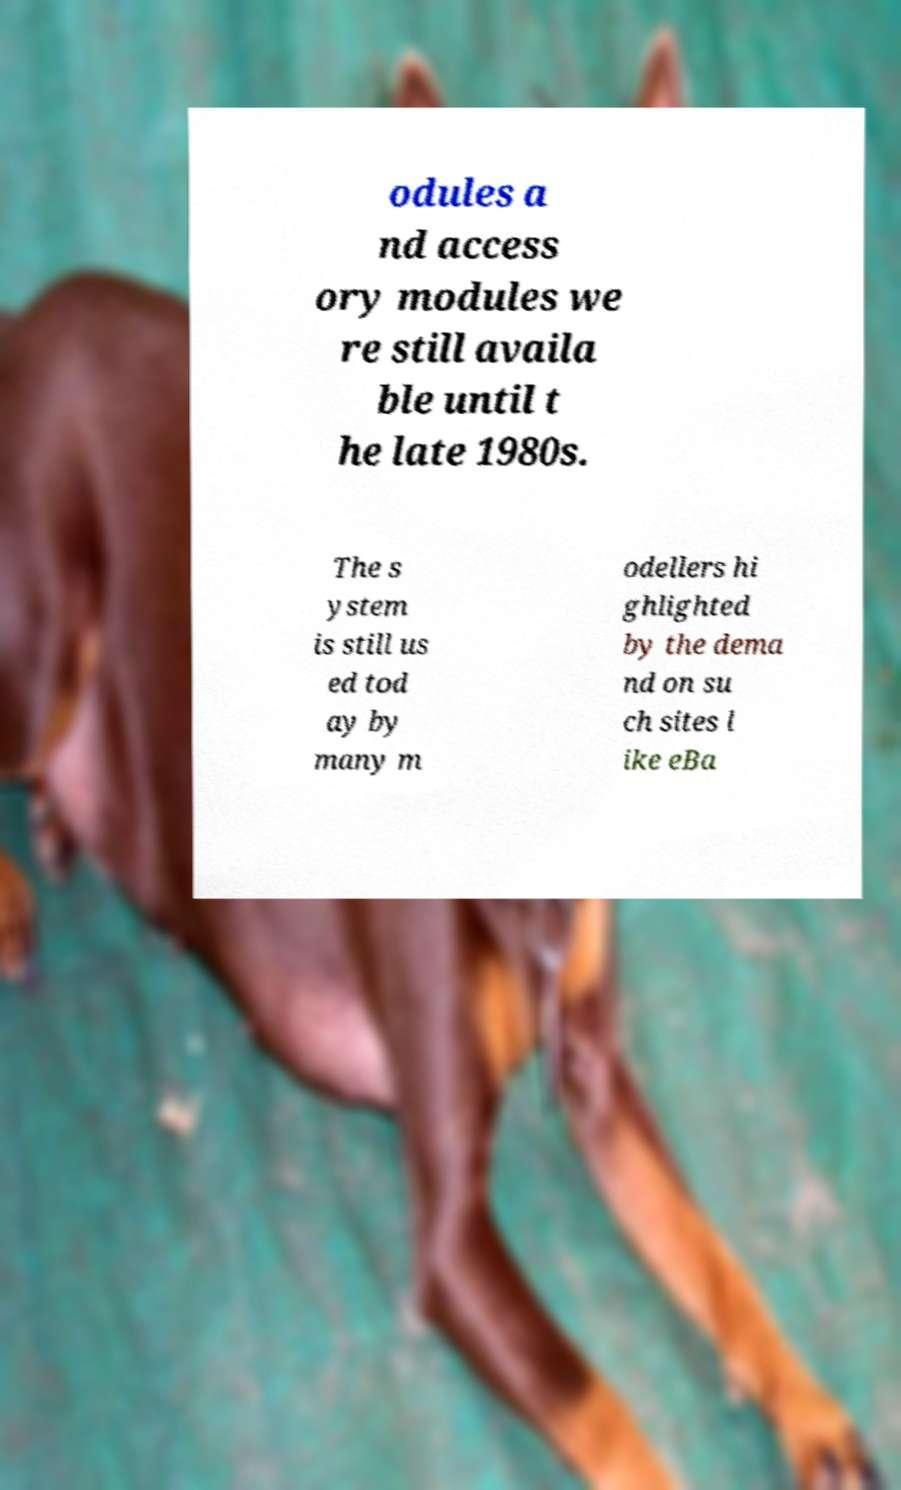Can you accurately transcribe the text from the provided image for me? odules a nd access ory modules we re still availa ble until t he late 1980s. The s ystem is still us ed tod ay by many m odellers hi ghlighted by the dema nd on su ch sites l ike eBa 